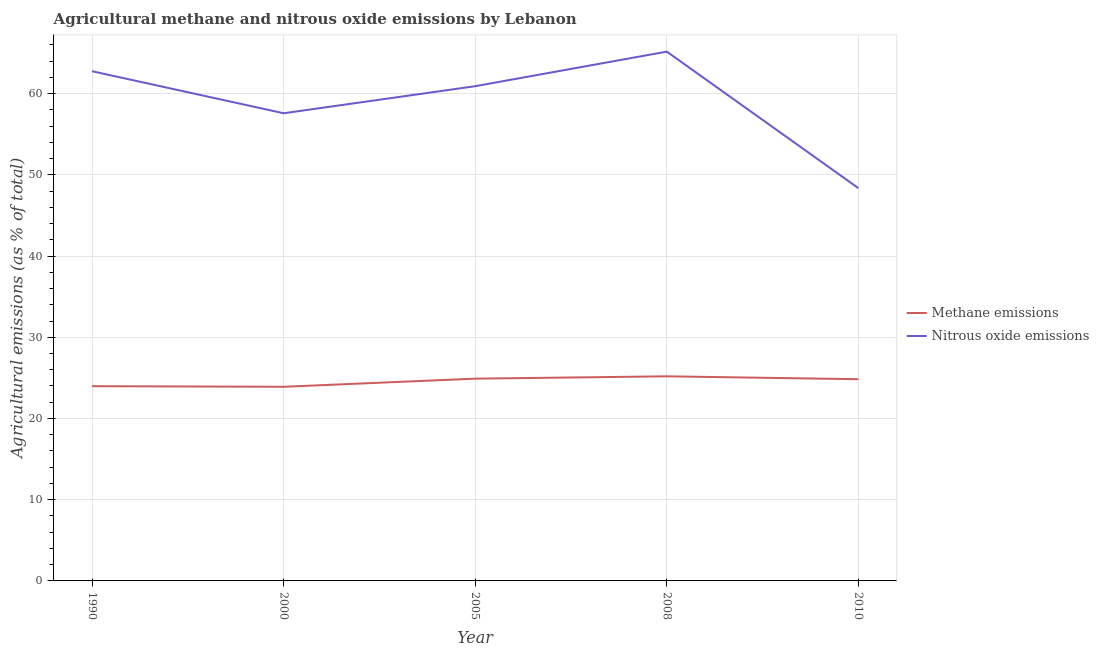Does the line corresponding to amount of methane emissions intersect with the line corresponding to amount of nitrous oxide emissions?
Your response must be concise. No. Is the number of lines equal to the number of legend labels?
Your answer should be very brief. Yes. What is the amount of nitrous oxide emissions in 2000?
Your response must be concise. 57.58. Across all years, what is the maximum amount of methane emissions?
Your answer should be compact. 25.19. Across all years, what is the minimum amount of methane emissions?
Give a very brief answer. 23.9. In which year was the amount of methane emissions minimum?
Provide a short and direct response. 2000. What is the total amount of nitrous oxide emissions in the graph?
Offer a terse response. 294.77. What is the difference between the amount of nitrous oxide emissions in 2005 and that in 2010?
Offer a terse response. 12.55. What is the difference between the amount of nitrous oxide emissions in 2008 and the amount of methane emissions in 2000?
Offer a terse response. 41.26. What is the average amount of methane emissions per year?
Your answer should be compact. 24.56. In the year 2008, what is the difference between the amount of methane emissions and amount of nitrous oxide emissions?
Offer a terse response. -39.98. What is the ratio of the amount of methane emissions in 2005 to that in 2008?
Your response must be concise. 0.99. Is the difference between the amount of nitrous oxide emissions in 1990 and 2008 greater than the difference between the amount of methane emissions in 1990 and 2008?
Offer a terse response. No. What is the difference between the highest and the second highest amount of methane emissions?
Make the answer very short. 0.29. What is the difference between the highest and the lowest amount of methane emissions?
Ensure brevity in your answer.  1.29. Is the amount of methane emissions strictly greater than the amount of nitrous oxide emissions over the years?
Offer a very short reply. No. Is the amount of methane emissions strictly less than the amount of nitrous oxide emissions over the years?
Your answer should be compact. Yes. How many years are there in the graph?
Provide a short and direct response. 5. Does the graph contain grids?
Provide a succinct answer. Yes. Where does the legend appear in the graph?
Provide a short and direct response. Center right. What is the title of the graph?
Offer a very short reply. Agricultural methane and nitrous oxide emissions by Lebanon. What is the label or title of the X-axis?
Provide a short and direct response. Year. What is the label or title of the Y-axis?
Offer a terse response. Agricultural emissions (as % of total). What is the Agricultural emissions (as % of total) of Methane emissions in 1990?
Offer a terse response. 23.98. What is the Agricultural emissions (as % of total) in Nitrous oxide emissions in 1990?
Keep it short and to the point. 62.76. What is the Agricultural emissions (as % of total) in Methane emissions in 2000?
Your answer should be compact. 23.9. What is the Agricultural emissions (as % of total) of Nitrous oxide emissions in 2000?
Your answer should be very brief. 57.58. What is the Agricultural emissions (as % of total) in Methane emissions in 2005?
Your response must be concise. 24.9. What is the Agricultural emissions (as % of total) of Nitrous oxide emissions in 2005?
Give a very brief answer. 60.91. What is the Agricultural emissions (as % of total) in Methane emissions in 2008?
Your answer should be very brief. 25.19. What is the Agricultural emissions (as % of total) of Nitrous oxide emissions in 2008?
Make the answer very short. 65.17. What is the Agricultural emissions (as % of total) of Methane emissions in 2010?
Your answer should be compact. 24.84. What is the Agricultural emissions (as % of total) of Nitrous oxide emissions in 2010?
Provide a short and direct response. 48.36. Across all years, what is the maximum Agricultural emissions (as % of total) of Methane emissions?
Make the answer very short. 25.19. Across all years, what is the maximum Agricultural emissions (as % of total) in Nitrous oxide emissions?
Ensure brevity in your answer.  65.17. Across all years, what is the minimum Agricultural emissions (as % of total) of Methane emissions?
Ensure brevity in your answer.  23.9. Across all years, what is the minimum Agricultural emissions (as % of total) in Nitrous oxide emissions?
Ensure brevity in your answer.  48.36. What is the total Agricultural emissions (as % of total) of Methane emissions in the graph?
Ensure brevity in your answer.  122.81. What is the total Agricultural emissions (as % of total) in Nitrous oxide emissions in the graph?
Your answer should be compact. 294.77. What is the difference between the Agricultural emissions (as % of total) of Methane emissions in 1990 and that in 2000?
Keep it short and to the point. 0.07. What is the difference between the Agricultural emissions (as % of total) of Nitrous oxide emissions in 1990 and that in 2000?
Offer a very short reply. 5.18. What is the difference between the Agricultural emissions (as % of total) in Methane emissions in 1990 and that in 2005?
Provide a short and direct response. -0.93. What is the difference between the Agricultural emissions (as % of total) of Nitrous oxide emissions in 1990 and that in 2005?
Give a very brief answer. 1.85. What is the difference between the Agricultural emissions (as % of total) in Methane emissions in 1990 and that in 2008?
Provide a short and direct response. -1.21. What is the difference between the Agricultural emissions (as % of total) of Nitrous oxide emissions in 1990 and that in 2008?
Your answer should be compact. -2.41. What is the difference between the Agricultural emissions (as % of total) in Methane emissions in 1990 and that in 2010?
Your answer should be very brief. -0.86. What is the difference between the Agricultural emissions (as % of total) in Nitrous oxide emissions in 1990 and that in 2010?
Make the answer very short. 14.4. What is the difference between the Agricultural emissions (as % of total) of Methane emissions in 2000 and that in 2005?
Give a very brief answer. -1. What is the difference between the Agricultural emissions (as % of total) in Nitrous oxide emissions in 2000 and that in 2005?
Your answer should be very brief. -3.33. What is the difference between the Agricultural emissions (as % of total) of Methane emissions in 2000 and that in 2008?
Your answer should be compact. -1.29. What is the difference between the Agricultural emissions (as % of total) in Nitrous oxide emissions in 2000 and that in 2008?
Provide a short and direct response. -7.59. What is the difference between the Agricultural emissions (as % of total) in Methane emissions in 2000 and that in 2010?
Offer a very short reply. -0.93. What is the difference between the Agricultural emissions (as % of total) of Nitrous oxide emissions in 2000 and that in 2010?
Make the answer very short. 9.22. What is the difference between the Agricultural emissions (as % of total) in Methane emissions in 2005 and that in 2008?
Offer a terse response. -0.29. What is the difference between the Agricultural emissions (as % of total) in Nitrous oxide emissions in 2005 and that in 2008?
Offer a terse response. -4.25. What is the difference between the Agricultural emissions (as % of total) of Methane emissions in 2005 and that in 2010?
Give a very brief answer. 0.07. What is the difference between the Agricultural emissions (as % of total) of Nitrous oxide emissions in 2005 and that in 2010?
Provide a succinct answer. 12.55. What is the difference between the Agricultural emissions (as % of total) of Methane emissions in 2008 and that in 2010?
Ensure brevity in your answer.  0.35. What is the difference between the Agricultural emissions (as % of total) of Nitrous oxide emissions in 2008 and that in 2010?
Provide a short and direct response. 16.81. What is the difference between the Agricultural emissions (as % of total) in Methane emissions in 1990 and the Agricultural emissions (as % of total) in Nitrous oxide emissions in 2000?
Your response must be concise. -33.6. What is the difference between the Agricultural emissions (as % of total) in Methane emissions in 1990 and the Agricultural emissions (as % of total) in Nitrous oxide emissions in 2005?
Offer a very short reply. -36.93. What is the difference between the Agricultural emissions (as % of total) of Methane emissions in 1990 and the Agricultural emissions (as % of total) of Nitrous oxide emissions in 2008?
Offer a very short reply. -41.19. What is the difference between the Agricultural emissions (as % of total) in Methane emissions in 1990 and the Agricultural emissions (as % of total) in Nitrous oxide emissions in 2010?
Give a very brief answer. -24.38. What is the difference between the Agricultural emissions (as % of total) in Methane emissions in 2000 and the Agricultural emissions (as % of total) in Nitrous oxide emissions in 2005?
Provide a succinct answer. -37.01. What is the difference between the Agricultural emissions (as % of total) in Methane emissions in 2000 and the Agricultural emissions (as % of total) in Nitrous oxide emissions in 2008?
Your response must be concise. -41.26. What is the difference between the Agricultural emissions (as % of total) in Methane emissions in 2000 and the Agricultural emissions (as % of total) in Nitrous oxide emissions in 2010?
Your answer should be very brief. -24.45. What is the difference between the Agricultural emissions (as % of total) in Methane emissions in 2005 and the Agricultural emissions (as % of total) in Nitrous oxide emissions in 2008?
Make the answer very short. -40.26. What is the difference between the Agricultural emissions (as % of total) of Methane emissions in 2005 and the Agricultural emissions (as % of total) of Nitrous oxide emissions in 2010?
Provide a succinct answer. -23.45. What is the difference between the Agricultural emissions (as % of total) in Methane emissions in 2008 and the Agricultural emissions (as % of total) in Nitrous oxide emissions in 2010?
Ensure brevity in your answer.  -23.17. What is the average Agricultural emissions (as % of total) of Methane emissions per year?
Offer a terse response. 24.56. What is the average Agricultural emissions (as % of total) in Nitrous oxide emissions per year?
Make the answer very short. 58.95. In the year 1990, what is the difference between the Agricultural emissions (as % of total) of Methane emissions and Agricultural emissions (as % of total) of Nitrous oxide emissions?
Offer a terse response. -38.78. In the year 2000, what is the difference between the Agricultural emissions (as % of total) of Methane emissions and Agricultural emissions (as % of total) of Nitrous oxide emissions?
Provide a succinct answer. -33.68. In the year 2005, what is the difference between the Agricultural emissions (as % of total) in Methane emissions and Agricultural emissions (as % of total) in Nitrous oxide emissions?
Ensure brevity in your answer.  -36.01. In the year 2008, what is the difference between the Agricultural emissions (as % of total) of Methane emissions and Agricultural emissions (as % of total) of Nitrous oxide emissions?
Make the answer very short. -39.98. In the year 2010, what is the difference between the Agricultural emissions (as % of total) in Methane emissions and Agricultural emissions (as % of total) in Nitrous oxide emissions?
Your answer should be very brief. -23.52. What is the ratio of the Agricultural emissions (as % of total) of Nitrous oxide emissions in 1990 to that in 2000?
Provide a succinct answer. 1.09. What is the ratio of the Agricultural emissions (as % of total) in Methane emissions in 1990 to that in 2005?
Give a very brief answer. 0.96. What is the ratio of the Agricultural emissions (as % of total) in Nitrous oxide emissions in 1990 to that in 2005?
Provide a succinct answer. 1.03. What is the ratio of the Agricultural emissions (as % of total) in Methane emissions in 1990 to that in 2008?
Offer a terse response. 0.95. What is the ratio of the Agricultural emissions (as % of total) of Nitrous oxide emissions in 1990 to that in 2008?
Offer a very short reply. 0.96. What is the ratio of the Agricultural emissions (as % of total) of Methane emissions in 1990 to that in 2010?
Give a very brief answer. 0.97. What is the ratio of the Agricultural emissions (as % of total) of Nitrous oxide emissions in 1990 to that in 2010?
Your answer should be compact. 1.3. What is the ratio of the Agricultural emissions (as % of total) of Methane emissions in 2000 to that in 2005?
Offer a terse response. 0.96. What is the ratio of the Agricultural emissions (as % of total) of Nitrous oxide emissions in 2000 to that in 2005?
Ensure brevity in your answer.  0.95. What is the ratio of the Agricultural emissions (as % of total) of Methane emissions in 2000 to that in 2008?
Your answer should be compact. 0.95. What is the ratio of the Agricultural emissions (as % of total) in Nitrous oxide emissions in 2000 to that in 2008?
Provide a succinct answer. 0.88. What is the ratio of the Agricultural emissions (as % of total) of Methane emissions in 2000 to that in 2010?
Provide a succinct answer. 0.96. What is the ratio of the Agricultural emissions (as % of total) of Nitrous oxide emissions in 2000 to that in 2010?
Your response must be concise. 1.19. What is the ratio of the Agricultural emissions (as % of total) of Nitrous oxide emissions in 2005 to that in 2008?
Provide a short and direct response. 0.93. What is the ratio of the Agricultural emissions (as % of total) in Nitrous oxide emissions in 2005 to that in 2010?
Offer a very short reply. 1.26. What is the ratio of the Agricultural emissions (as % of total) of Methane emissions in 2008 to that in 2010?
Ensure brevity in your answer.  1.01. What is the ratio of the Agricultural emissions (as % of total) in Nitrous oxide emissions in 2008 to that in 2010?
Your response must be concise. 1.35. What is the difference between the highest and the second highest Agricultural emissions (as % of total) of Methane emissions?
Your answer should be compact. 0.29. What is the difference between the highest and the second highest Agricultural emissions (as % of total) in Nitrous oxide emissions?
Your answer should be compact. 2.41. What is the difference between the highest and the lowest Agricultural emissions (as % of total) in Methane emissions?
Your answer should be very brief. 1.29. What is the difference between the highest and the lowest Agricultural emissions (as % of total) of Nitrous oxide emissions?
Your answer should be compact. 16.81. 